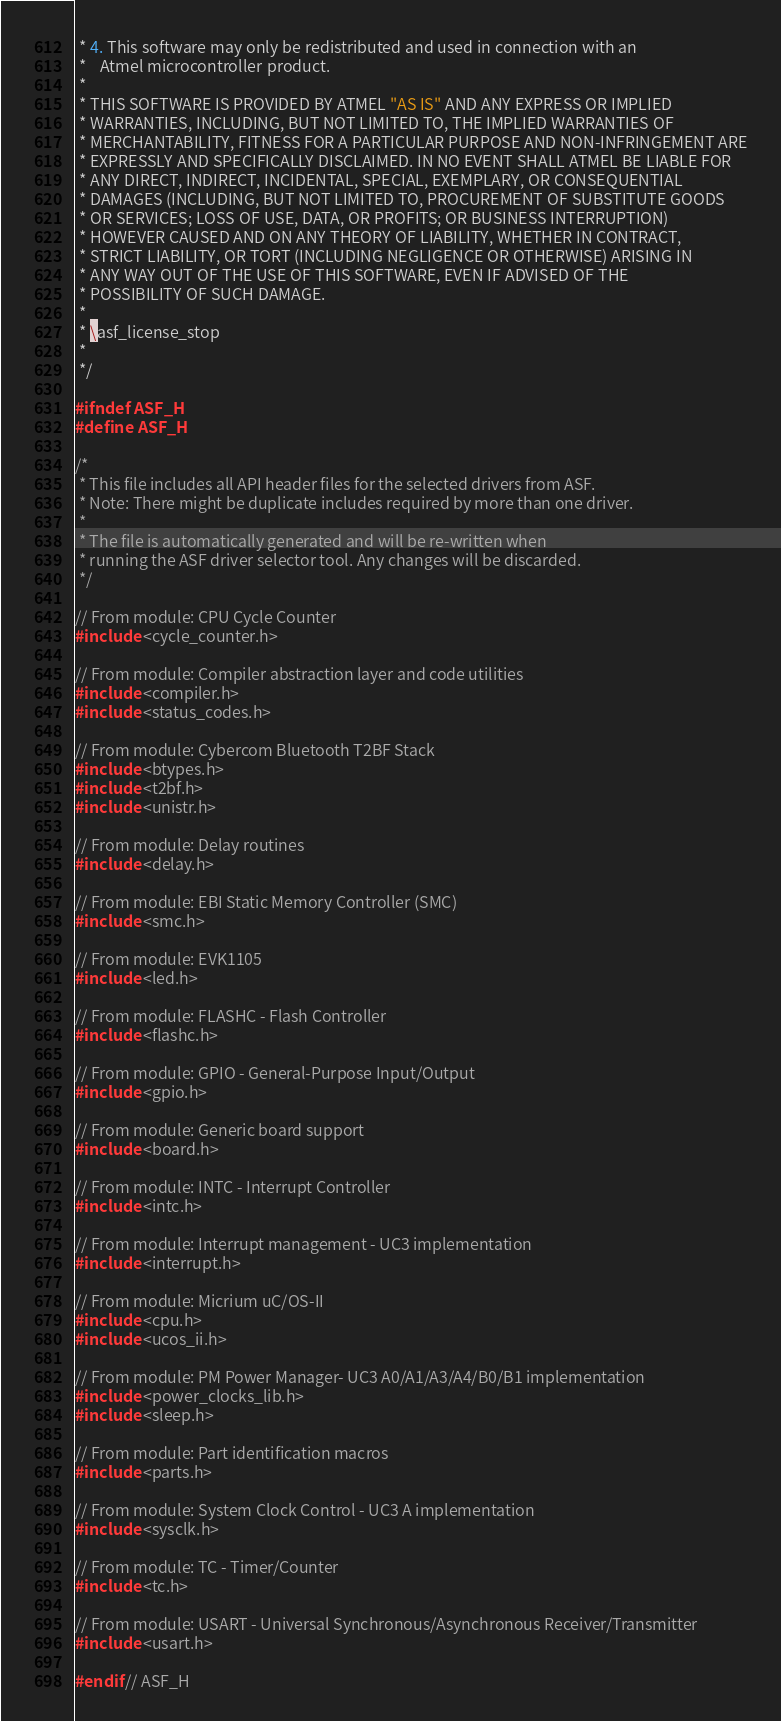<code> <loc_0><loc_0><loc_500><loc_500><_C_> * 4. This software may only be redistributed and used in connection with an
 *    Atmel microcontroller product.
 *
 * THIS SOFTWARE IS PROVIDED BY ATMEL "AS IS" AND ANY EXPRESS OR IMPLIED
 * WARRANTIES, INCLUDING, BUT NOT LIMITED TO, THE IMPLIED WARRANTIES OF
 * MERCHANTABILITY, FITNESS FOR A PARTICULAR PURPOSE AND NON-INFRINGEMENT ARE
 * EXPRESSLY AND SPECIFICALLY DISCLAIMED. IN NO EVENT SHALL ATMEL BE LIABLE FOR
 * ANY DIRECT, INDIRECT, INCIDENTAL, SPECIAL, EXEMPLARY, OR CONSEQUENTIAL
 * DAMAGES (INCLUDING, BUT NOT LIMITED TO, PROCUREMENT OF SUBSTITUTE GOODS
 * OR SERVICES; LOSS OF USE, DATA, OR PROFITS; OR BUSINESS INTERRUPTION)
 * HOWEVER CAUSED AND ON ANY THEORY OF LIABILITY, WHETHER IN CONTRACT,
 * STRICT LIABILITY, OR TORT (INCLUDING NEGLIGENCE OR OTHERWISE) ARISING IN
 * ANY WAY OUT OF THE USE OF THIS SOFTWARE, EVEN IF ADVISED OF THE
 * POSSIBILITY OF SUCH DAMAGE.
 *
 * \asf_license_stop
 *
 */

#ifndef ASF_H
#define ASF_H

/*
 * This file includes all API header files for the selected drivers from ASF.
 * Note: There might be duplicate includes required by more than one driver.
 *
 * The file is automatically generated and will be re-written when
 * running the ASF driver selector tool. Any changes will be discarded.
 */

// From module: CPU Cycle Counter
#include <cycle_counter.h>

// From module: Compiler abstraction layer and code utilities
#include <compiler.h>
#include <status_codes.h>

// From module: Cybercom Bluetooth T2BF Stack
#include <btypes.h>
#include <t2bf.h>
#include <unistr.h>

// From module: Delay routines
#include <delay.h>

// From module: EBI Static Memory Controller (SMC)
#include <smc.h>

// From module: EVK1105
#include <led.h>

// From module: FLASHC - Flash Controller
#include <flashc.h>

// From module: GPIO - General-Purpose Input/Output
#include <gpio.h>

// From module: Generic board support
#include <board.h>

// From module: INTC - Interrupt Controller
#include <intc.h>

// From module: Interrupt management - UC3 implementation
#include <interrupt.h>

// From module: Micrium uC/OS-II
#include <cpu.h>
#include <ucos_ii.h>

// From module: PM Power Manager- UC3 A0/A1/A3/A4/B0/B1 implementation
#include <power_clocks_lib.h>
#include <sleep.h>

// From module: Part identification macros
#include <parts.h>

// From module: System Clock Control - UC3 A implementation
#include <sysclk.h>

// From module: TC - Timer/Counter
#include <tc.h>

// From module: USART - Universal Synchronous/Asynchronous Receiver/Transmitter
#include <usart.h>

#endif // ASF_H
</code> 